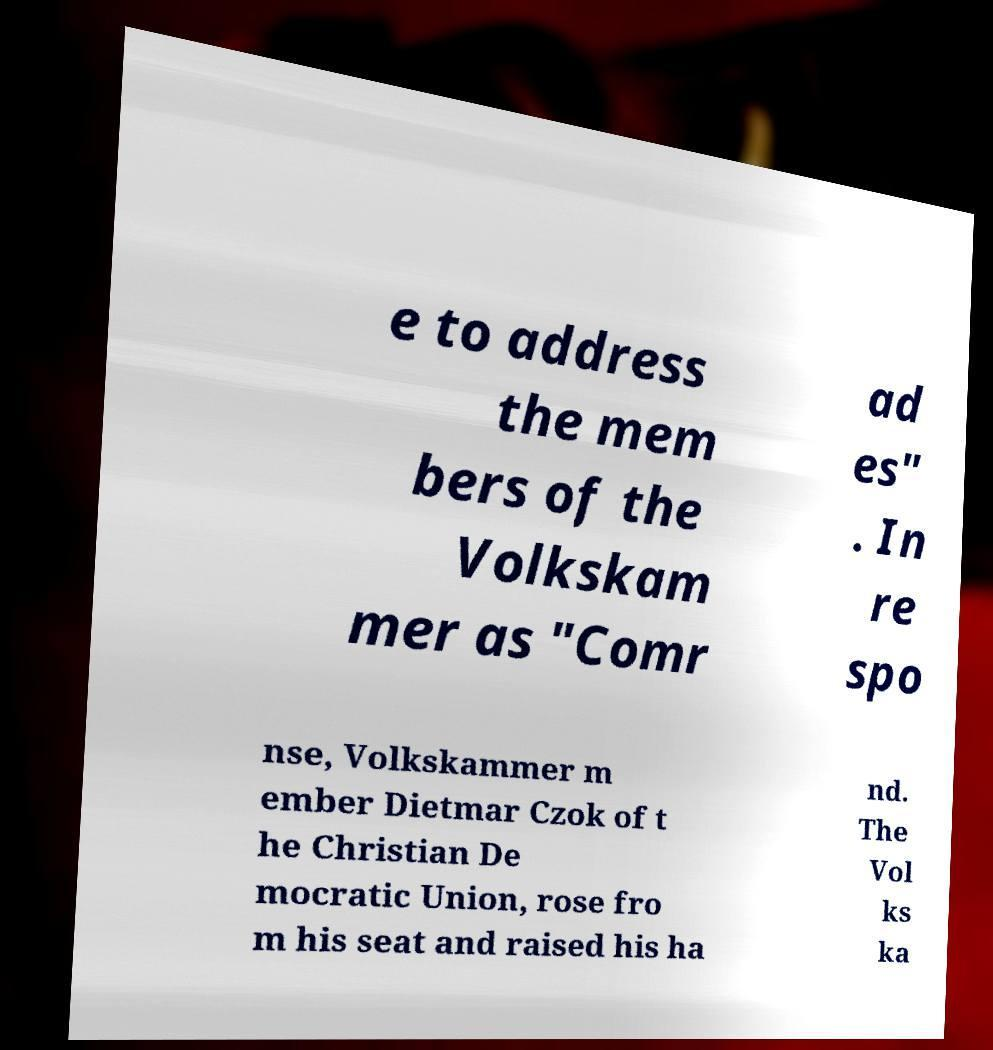What messages or text are displayed in this image? I need them in a readable, typed format. e to address the mem bers of the Volkskam mer as "Comr ad es" . In re spo nse, Volkskammer m ember Dietmar Czok of t he Christian De mocratic Union, rose fro m his seat and raised his ha nd. The Vol ks ka 